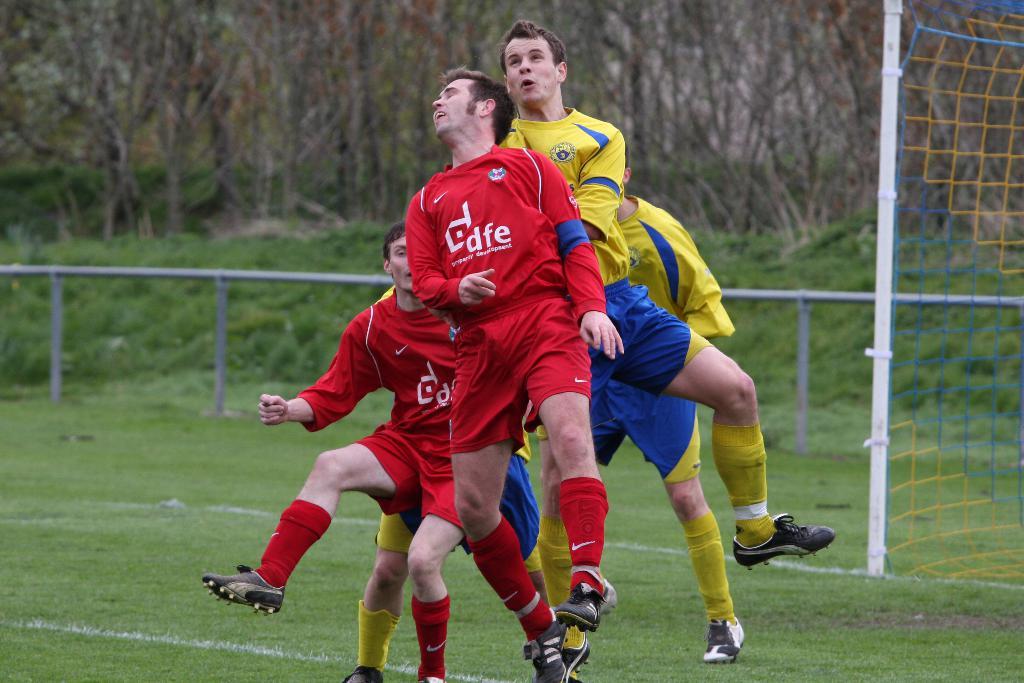Who does red play for?
Offer a terse response. Dfe. What are the large white letters on the red shirt?
Give a very brief answer. Dfe. 